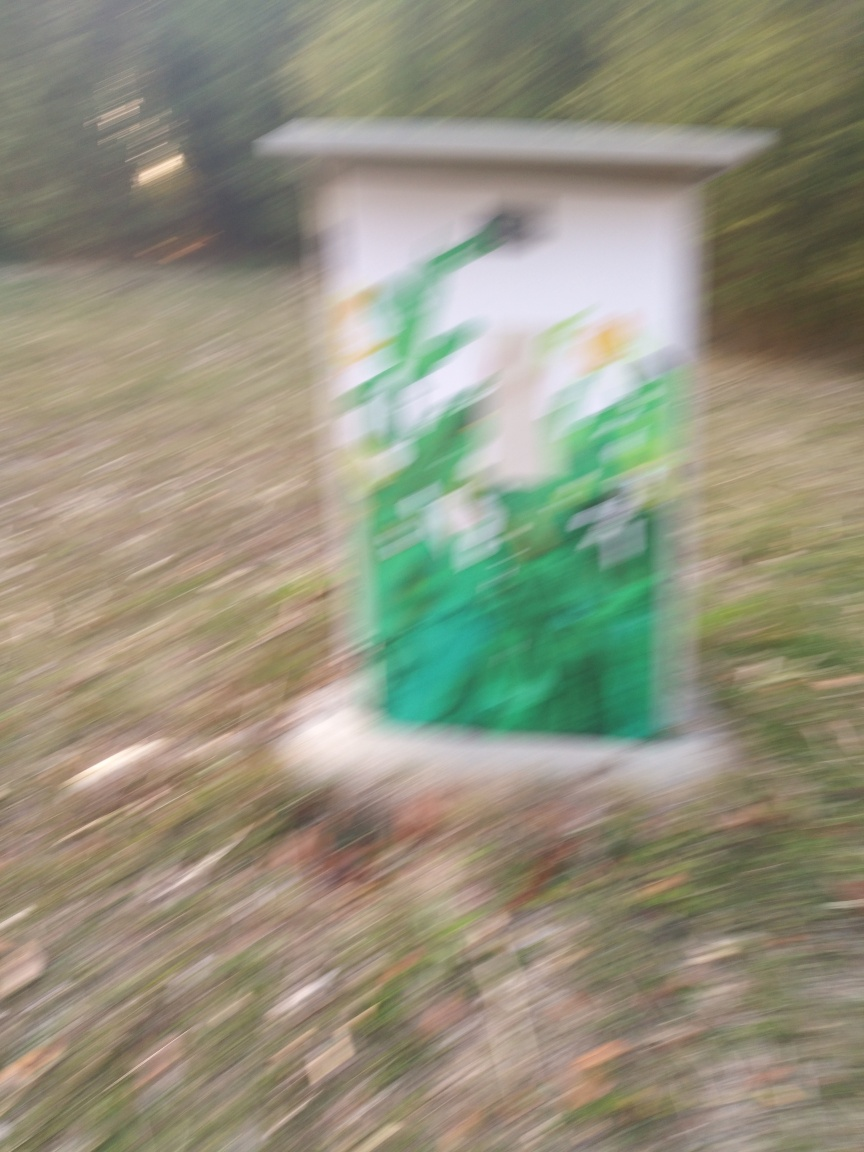Can you identify any objects or structures in this image? Although the image is blurry, there seems to be a rectangular structure, possibly an electrical or utility box, at the center. It has some sort of graphic or graffiti on it, with predominately green color and hints of other colors. 